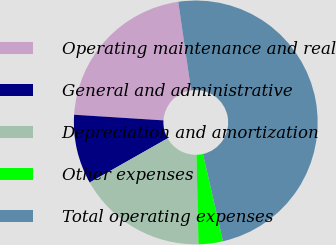<chart> <loc_0><loc_0><loc_500><loc_500><pie_chart><fcel>Operating maintenance and real<fcel>General and administrative<fcel>Depreciation and amortization<fcel>Other expenses<fcel>Total operating expenses<nl><fcel>21.7%<fcel>9.21%<fcel>17.15%<fcel>3.23%<fcel>48.71%<nl></chart> 